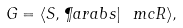Convert formula to latex. <formula><loc_0><loc_0><loc_500><loc_500>G = \langle S , \P a r a b s | \ m c { R } \rangle ,</formula> 